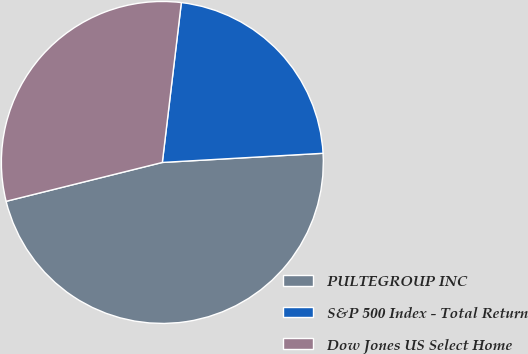Convert chart. <chart><loc_0><loc_0><loc_500><loc_500><pie_chart><fcel>PULTEGROUP INC<fcel>S&P 500 Index - Total Return<fcel>Dow Jones US Select Home<nl><fcel>47.03%<fcel>22.21%<fcel>30.77%<nl></chart> 